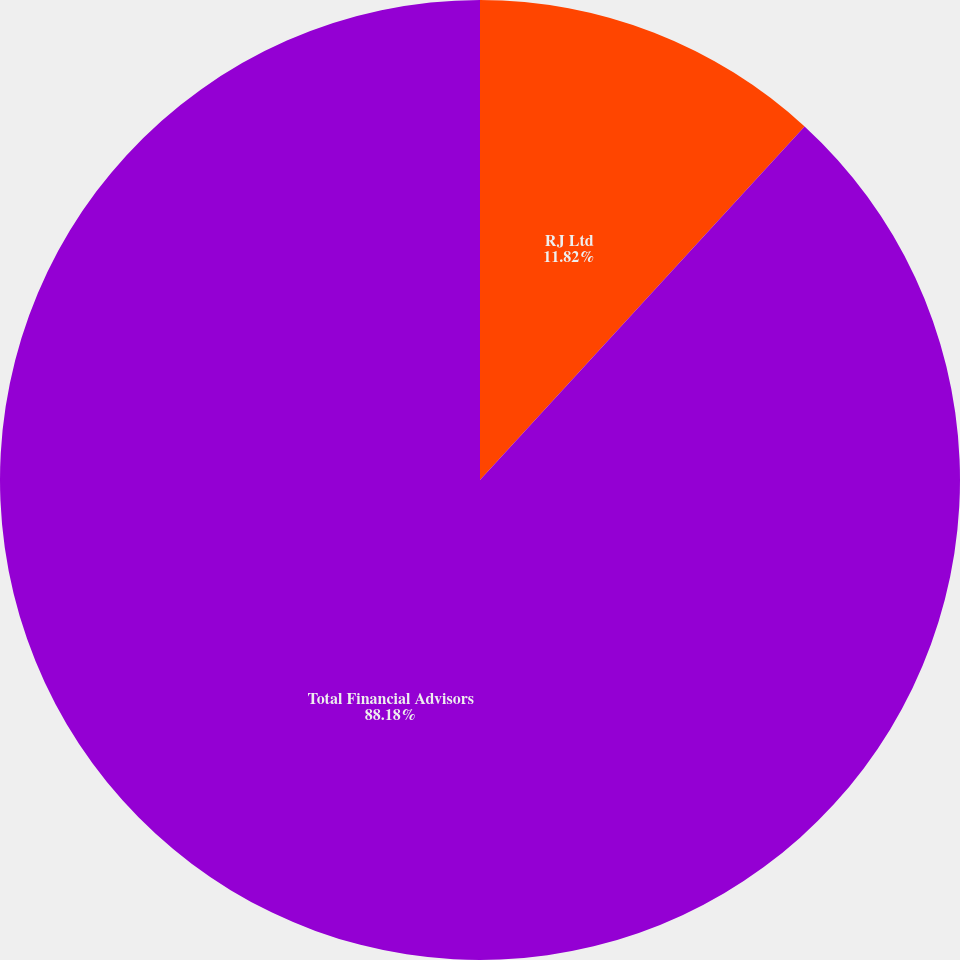Convert chart. <chart><loc_0><loc_0><loc_500><loc_500><pie_chart><fcel>RJ Ltd<fcel>Total Financial Advisors<nl><fcel>11.82%<fcel>88.18%<nl></chart> 